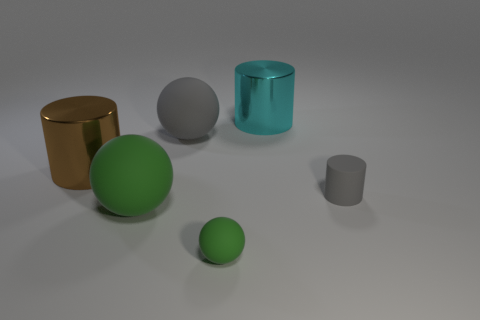Add 1 yellow metallic cubes. How many objects exist? 7 Subtract all green spheres. How many spheres are left? 1 Subtract all brown cylinders. How many gray balls are left? 1 Subtract all green spheres. How many spheres are left? 1 Subtract all gray matte objects. Subtract all yellow matte spheres. How many objects are left? 4 Add 2 gray objects. How many gray objects are left? 4 Add 1 big gray things. How many big gray things exist? 2 Subtract 0 blue cylinders. How many objects are left? 6 Subtract all cyan balls. Subtract all blue cylinders. How many balls are left? 3 